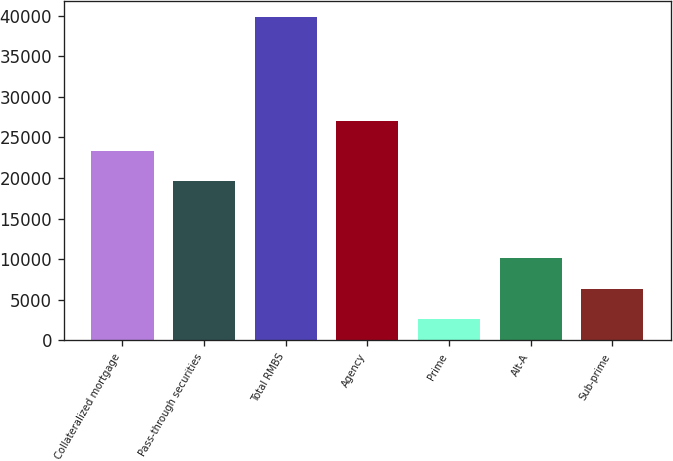Convert chart to OTSL. <chart><loc_0><loc_0><loc_500><loc_500><bar_chart><fcel>Collateralized mortgage<fcel>Pass-through securities<fcel>Total RMBS<fcel>Agency<fcel>Prime<fcel>Alt-A<fcel>Sub-prime<nl><fcel>23296.8<fcel>19577<fcel>39846<fcel>27016.6<fcel>2648<fcel>10087.6<fcel>6367.8<nl></chart> 